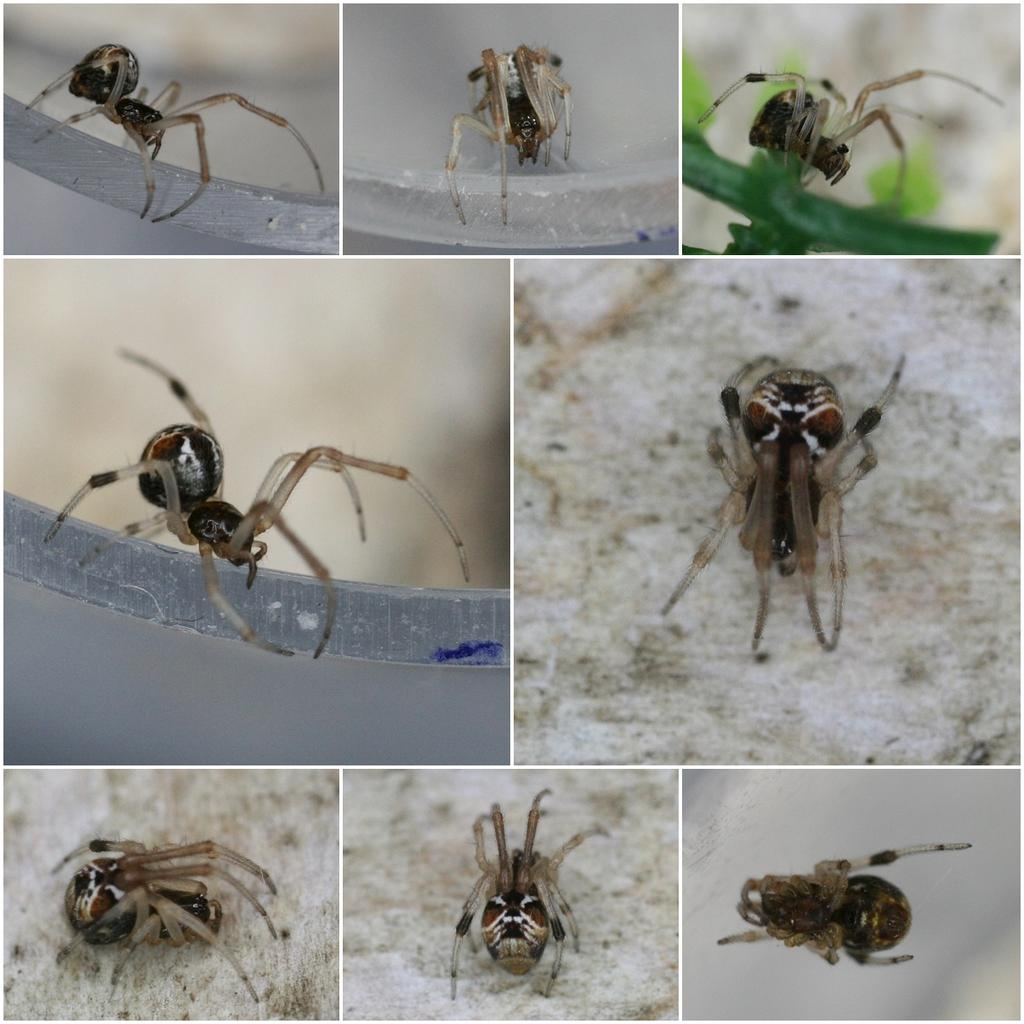What is the main subject of the image? There is a spider in the image. What color is the background of the image? The background of the image is white. Can you tell me how many tigers are in the store in the image? There are no tigers or stores present in the image; it features a spider against a white background. What type of band is playing in the background of the image? There is no band present in the image; it features a spider against a white background. 